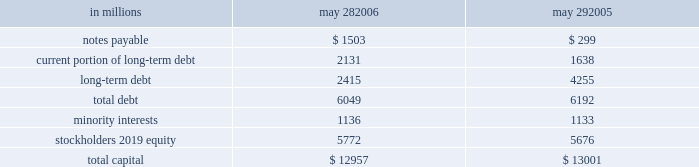During fiscal 2006 , we repurchased 19 million shares of common stock for an aggregate purchase price of $ 892 million , of which $ 7 million settled after the end of our fiscal year .
In fiscal 2005 , we repurchased 17 million shares of common stock for an aggregate purchase price of $ 771 million .
A total of 146 million shares were held in treasury at may 28 , 2006 .
We also used cash from operations to repay $ 189 million in outstanding debt in fiscal 2006 .
In fiscal 2005 , we repaid nearly $ 2.2 billion of debt , including the purchase of $ 760 million principal amount of our 6 percent notes due in 2012 .
Fiscal 2005 debt repurchase costs were $ 137 million , consisting of $ 73 million of noncash interest rate swap losses reclassified from accumulated other comprehen- sive income , $ 59 million of purchase premium and $ 5 million of noncash unamortized cost of issuance expense .
Capital structure in millions may 28 , may 29 .
We have $ 2.1 billion of long-term debt maturing in the next 12 months and classified as current , including $ 131 million that may mature in fiscal 2007 based on the put rights of those note holders .
We believe that cash flows from operations , together with available short- and long- term debt financing , will be adequate to meet our liquidity and capital needs for at least the next 12 months .
On october 28 , 2005 , we repurchased a significant portion of our zero coupon convertible debentures pursuant to put rights of the holders for an aggregate purchase price of $ 1.33 billion , including $ 77 million of accreted original issue discount .
These debentures had an aggregate prin- cipal amount at maturity of $ 1.86 billion .
We incurred no gain or loss from this repurchase .
As of may 28 , 2006 , there were $ 371 million in aggregate principal amount at matu- rity of the debentures outstanding , or $ 268 million of accreted value .
We used proceeds from the issuance of commercial paper to fund the purchase price of the deben- tures .
We also have reclassified the remaining zero coupon convertible debentures to long-term debt based on the october 2008 put rights of the holders .
On march 23 , 2005 , we commenced a cash tender offer for our outstanding 6 percent notes due in 2012 .
The tender offer resulted in the purchase of $ 500 million principal amount of the notes .
Subsequent to the expiration of the tender offer , we purchased an additional $ 260 million prin- cipal amount of the notes in the open market .
The aggregate purchases resulted in the debt repurchase costs as discussed above .
Our minority interests consist of interests in certain of our subsidiaries that are held by third parties .
General mills cereals , llc ( gmc ) , our subsidiary , holds the manufac- turing assets and intellectual property associated with the production and retail sale of big g ready-to-eat cereals , progresso soups and old el paso products .
In may 2002 , one of our wholly owned subsidiaries sold 150000 class a preferred membership interests in gmc to an unrelated third-party investor in exchange for $ 150 million , and in october 2004 , another of our wholly owned subsidiaries sold 835000 series b-1 preferred membership interests in gmc in exchange for $ 835 million .
All interests in gmc , other than the 150000 class a interests and 835000 series b-1 interests , but including all managing member inter- ests , are held by our wholly owned subsidiaries .
In fiscal 2003 , general mills capital , inc .
( gm capital ) , a subsidiary formed for the purpose of purchasing and collecting our receivables , sold $ 150 million of its series a preferred stock to an unrelated third-party investor .
The class a interests of gmc receive quarterly preferred distributions at a floating rate equal to ( i ) the sum of three- month libor plus 90 basis points , divided by ( ii ) 0.965 .
This rate will be adjusted by agreement between the third- party investor holding the class a interests and gmc every five years , beginning in june 2007 .
Under certain circum- stances , gmc also may be required to be dissolved and liquidated , including , without limitation , the bankruptcy of gmc or its subsidiaries , failure to deliver the preferred distributions , failure to comply with portfolio requirements , breaches of certain covenants , lowering of our senior debt rating below either baa3 by moody 2019s or bbb by standard & poor 2019s , and a failed attempt to remarket the class a inter- ests as a result of a breach of gmc 2019s obligations to assist in such remarketing .
In the event of a liquidation of gmc , each member of gmc would receive the amount of its then current capital account balance .
The managing member may avoid liquidation in most circumstances by exercising an option to purchase the class a interests .
The series b-1 interests of gmc are entitled to receive quarterly preferred distributions at a fixed rate of 4.5 percent per year , which is scheduled to be reset to a new fixed rate through a remarketing in october 2007 .
Beginning in october 2007 , the managing member of gmc may elect to repurchase the series b-1 interests for an amount equal to the holder 2019s then current capital account balance plus any applicable make-whole amount .
Gmc is not required to purchase the series b-1 interests nor may these investors put these interests to us .
The series b-1 interests will be exchanged for shares of our perpetual preferred stock upon the occurrence of any of the following events : our senior unsecured debt rating falling below either ba3 as rated by moody 2019s or bb- as rated by standard & poor 2019s or fitch , inc. .
What is the average price per share for the repurchased shares during 2006? 
Computations: (892 / 19)
Answer: 46.94737. 